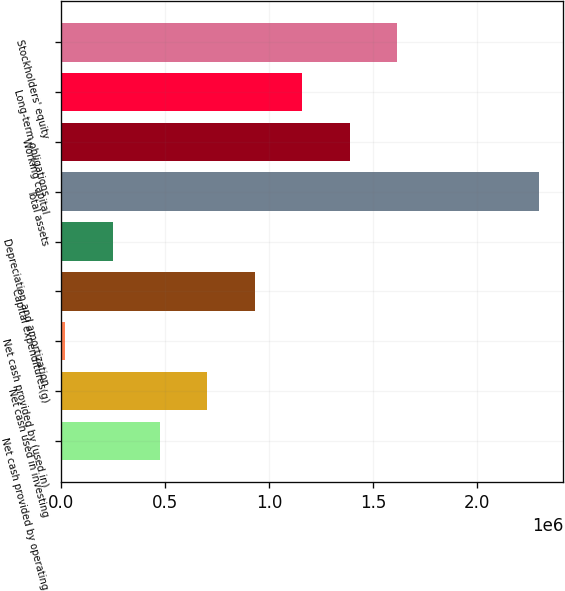Convert chart. <chart><loc_0><loc_0><loc_500><loc_500><bar_chart><fcel>Net cash provided by operating<fcel>Net cash used in investing<fcel>Net cash provided by (used in)<fcel>Capital expenditures(g)<fcel>Depreciation and amortization<fcel>Total assets<fcel>Working capital<fcel>Long-term obligations<fcel>Stockholders' equity<nl><fcel>475071<fcel>703126<fcel>18962<fcel>931181<fcel>247017<fcel>2.29951e+06<fcel>1.38729e+06<fcel>1.15924e+06<fcel>1.61534e+06<nl></chart> 